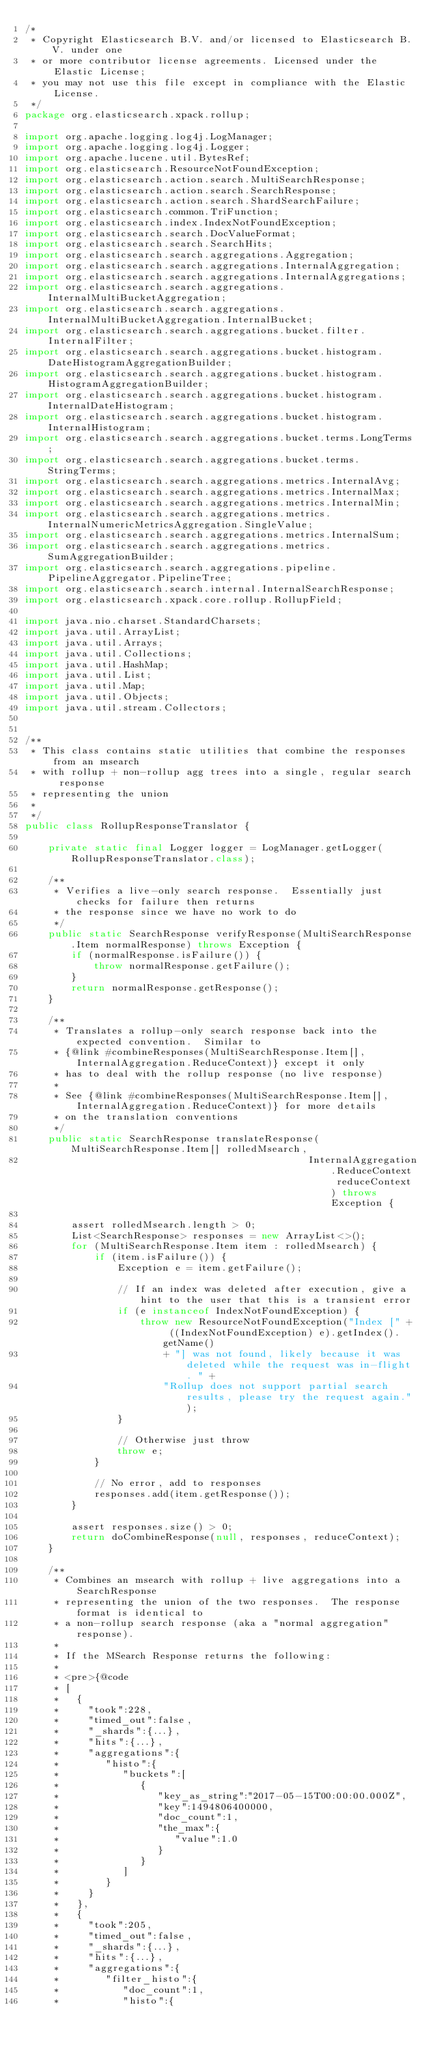Convert code to text. <code><loc_0><loc_0><loc_500><loc_500><_Java_>/*
 * Copyright Elasticsearch B.V. and/or licensed to Elasticsearch B.V. under one
 * or more contributor license agreements. Licensed under the Elastic License;
 * you may not use this file except in compliance with the Elastic License.
 */
package org.elasticsearch.xpack.rollup;

import org.apache.logging.log4j.LogManager;
import org.apache.logging.log4j.Logger;
import org.apache.lucene.util.BytesRef;
import org.elasticsearch.ResourceNotFoundException;
import org.elasticsearch.action.search.MultiSearchResponse;
import org.elasticsearch.action.search.SearchResponse;
import org.elasticsearch.action.search.ShardSearchFailure;
import org.elasticsearch.common.TriFunction;
import org.elasticsearch.index.IndexNotFoundException;
import org.elasticsearch.search.DocValueFormat;
import org.elasticsearch.search.SearchHits;
import org.elasticsearch.search.aggregations.Aggregation;
import org.elasticsearch.search.aggregations.InternalAggregation;
import org.elasticsearch.search.aggregations.InternalAggregations;
import org.elasticsearch.search.aggregations.InternalMultiBucketAggregation;
import org.elasticsearch.search.aggregations.InternalMultiBucketAggregation.InternalBucket;
import org.elasticsearch.search.aggregations.bucket.filter.InternalFilter;
import org.elasticsearch.search.aggregations.bucket.histogram.DateHistogramAggregationBuilder;
import org.elasticsearch.search.aggregations.bucket.histogram.HistogramAggregationBuilder;
import org.elasticsearch.search.aggregations.bucket.histogram.InternalDateHistogram;
import org.elasticsearch.search.aggregations.bucket.histogram.InternalHistogram;
import org.elasticsearch.search.aggregations.bucket.terms.LongTerms;
import org.elasticsearch.search.aggregations.bucket.terms.StringTerms;
import org.elasticsearch.search.aggregations.metrics.InternalAvg;
import org.elasticsearch.search.aggregations.metrics.InternalMax;
import org.elasticsearch.search.aggregations.metrics.InternalMin;
import org.elasticsearch.search.aggregations.metrics.InternalNumericMetricsAggregation.SingleValue;
import org.elasticsearch.search.aggregations.metrics.InternalSum;
import org.elasticsearch.search.aggregations.metrics.SumAggregationBuilder;
import org.elasticsearch.search.aggregations.pipeline.PipelineAggregator.PipelineTree;
import org.elasticsearch.search.internal.InternalSearchResponse;
import org.elasticsearch.xpack.core.rollup.RollupField;

import java.nio.charset.StandardCharsets;
import java.util.ArrayList;
import java.util.Arrays;
import java.util.Collections;
import java.util.HashMap;
import java.util.List;
import java.util.Map;
import java.util.Objects;
import java.util.stream.Collectors;


/**
 * This class contains static utilities that combine the responses from an msearch
 * with rollup + non-rollup agg trees into a single, regular search response
 * representing the union
 *
 */
public class RollupResponseTranslator {

    private static final Logger logger = LogManager.getLogger(RollupResponseTranslator.class);

    /**
     * Verifies a live-only search response.  Essentially just checks for failure then returns
     * the response since we have no work to do
     */
    public static SearchResponse verifyResponse(MultiSearchResponse.Item normalResponse) throws Exception {
        if (normalResponse.isFailure()) {
            throw normalResponse.getFailure();
        }
        return normalResponse.getResponse();
    }

    /**
     * Translates a rollup-only search response back into the expected convention.  Similar to
     * {@link #combineResponses(MultiSearchResponse.Item[], InternalAggregation.ReduceContext)} except it only
     * has to deal with the rollup response (no live response)
     *
     * See {@link #combineResponses(MultiSearchResponse.Item[], InternalAggregation.ReduceContext)} for more details
     * on the translation conventions
     */
    public static SearchResponse translateResponse(MultiSearchResponse.Item[] rolledMsearch,
                                                 InternalAggregation.ReduceContext reduceContext) throws Exception {

        assert rolledMsearch.length > 0;
        List<SearchResponse> responses = new ArrayList<>();
        for (MultiSearchResponse.Item item : rolledMsearch) {
            if (item.isFailure()) {
                Exception e = item.getFailure();

                // If an index was deleted after execution, give a hint to the user that this is a transient error
                if (e instanceof IndexNotFoundException) {
                    throw new ResourceNotFoundException("Index [" + ((IndexNotFoundException) e).getIndex().getName()
                        + "] was not found, likely because it was deleted while the request was in-flight. " +
                        "Rollup does not support partial search results, please try the request again.");
                }

                // Otherwise just throw
                throw e;
            }

            // No error, add to responses
            responses.add(item.getResponse());
        }

        assert responses.size() > 0;
        return doCombineResponse(null, responses, reduceContext);
    }

    /**
     * Combines an msearch with rollup + live aggregations into a SearchResponse
     * representing the union of the two responses.  The response format is identical to
     * a non-rollup search response (aka a "normal aggregation" response).
     *
     * If the MSearch Response returns the following:
     *
     * <pre>{@code
     * [
     *   {
     *     "took":228,
     *     "timed_out":false,
     *     "_shards":{...},
     *     "hits":{...},
     *     "aggregations":{
     *        "histo":{
     *           "buckets":[
     *              {
     *                 "key_as_string":"2017-05-15T00:00:00.000Z",
     *                 "key":1494806400000,
     *                 "doc_count":1,
     *                 "the_max":{
     *                    "value":1.0
     *                 }
     *              }
     *           ]
     *        }
     *     }
     *   },
     *   {
     *     "took":205,
     *     "timed_out":false,
     *     "_shards":{...},
     *     "hits":{...},
     *     "aggregations":{
     *        "filter_histo":{
     *           "doc_count":1,
     *           "histo":{</code> 